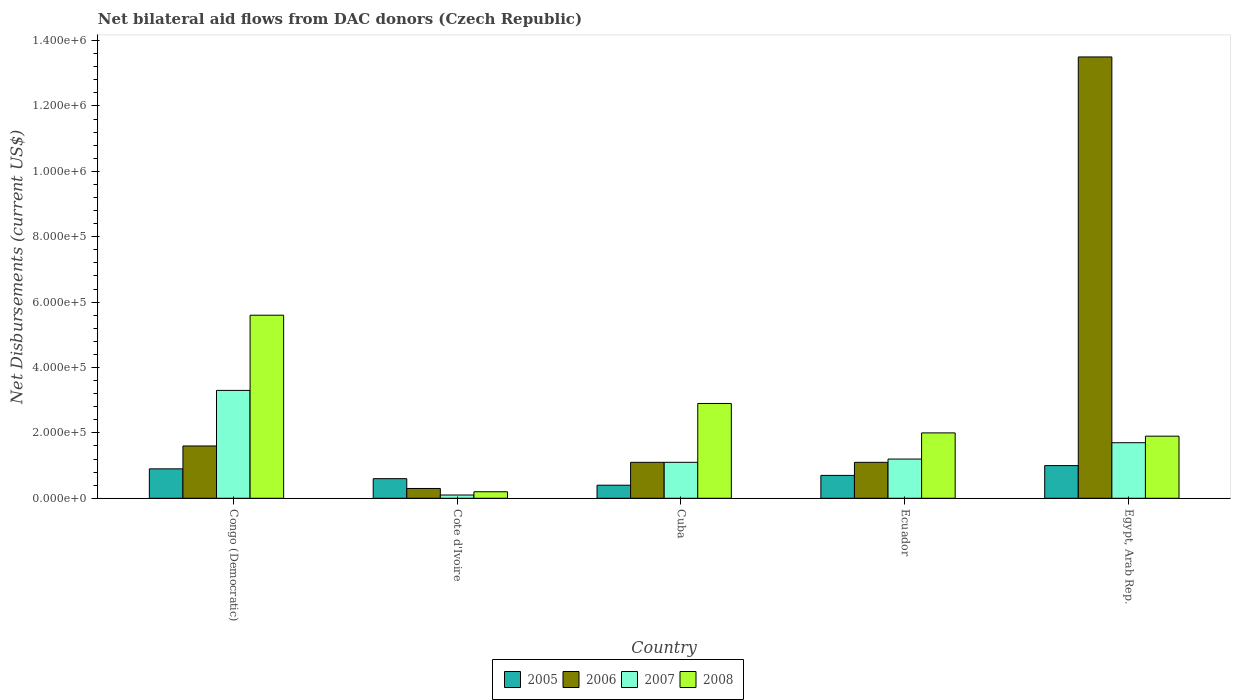How many groups of bars are there?
Offer a very short reply. 5. Are the number of bars per tick equal to the number of legend labels?
Provide a short and direct response. Yes. How many bars are there on the 5th tick from the left?
Make the answer very short. 4. How many bars are there on the 5th tick from the right?
Your response must be concise. 4. What is the label of the 3rd group of bars from the left?
Your answer should be compact. Cuba. In which country was the net bilateral aid flows in 2005 maximum?
Keep it short and to the point. Egypt, Arab Rep. In which country was the net bilateral aid flows in 2008 minimum?
Ensure brevity in your answer.  Cote d'Ivoire. What is the total net bilateral aid flows in 2006 in the graph?
Provide a short and direct response. 1.76e+06. What is the difference between the net bilateral aid flows in 2005 in Congo (Democratic) and the net bilateral aid flows in 2006 in Ecuador?
Your answer should be compact. -2.00e+04. What is the average net bilateral aid flows in 2005 per country?
Make the answer very short. 7.20e+04. What is the difference between the net bilateral aid flows of/in 2005 and net bilateral aid flows of/in 2007 in Ecuador?
Your answer should be compact. -5.00e+04. In how many countries, is the net bilateral aid flows in 2008 greater than 600000 US$?
Keep it short and to the point. 0. What is the ratio of the net bilateral aid flows in 2006 in Congo (Democratic) to that in Egypt, Arab Rep.?
Your answer should be compact. 0.12. Is the net bilateral aid flows in 2005 in Congo (Democratic) less than that in Ecuador?
Provide a short and direct response. No. What is the difference between the highest and the second highest net bilateral aid flows in 2008?
Provide a succinct answer. 3.60e+05. In how many countries, is the net bilateral aid flows in 2005 greater than the average net bilateral aid flows in 2005 taken over all countries?
Offer a very short reply. 2. Is the sum of the net bilateral aid flows in 2005 in Cuba and Ecuador greater than the maximum net bilateral aid flows in 2006 across all countries?
Make the answer very short. No. Is it the case that in every country, the sum of the net bilateral aid flows in 2006 and net bilateral aid flows in 2005 is greater than the sum of net bilateral aid flows in 2007 and net bilateral aid flows in 2008?
Keep it short and to the point. No. What does the 1st bar from the left in Egypt, Arab Rep. represents?
Your answer should be compact. 2005. What does the 1st bar from the right in Cote d'Ivoire represents?
Your response must be concise. 2008. Is it the case that in every country, the sum of the net bilateral aid flows in 2008 and net bilateral aid flows in 2006 is greater than the net bilateral aid flows in 2005?
Provide a short and direct response. No. How many countries are there in the graph?
Provide a short and direct response. 5. Are the values on the major ticks of Y-axis written in scientific E-notation?
Your answer should be very brief. Yes. Does the graph contain any zero values?
Your response must be concise. No. Where does the legend appear in the graph?
Offer a terse response. Bottom center. What is the title of the graph?
Provide a short and direct response. Net bilateral aid flows from DAC donors (Czech Republic). What is the label or title of the X-axis?
Your answer should be compact. Country. What is the label or title of the Y-axis?
Make the answer very short. Net Disbursements (current US$). What is the Net Disbursements (current US$) of 2006 in Congo (Democratic)?
Your answer should be very brief. 1.60e+05. What is the Net Disbursements (current US$) of 2008 in Congo (Democratic)?
Give a very brief answer. 5.60e+05. What is the Net Disbursements (current US$) in 2005 in Cote d'Ivoire?
Your answer should be very brief. 6.00e+04. What is the Net Disbursements (current US$) of 2008 in Cote d'Ivoire?
Ensure brevity in your answer.  2.00e+04. What is the Net Disbursements (current US$) of 2005 in Cuba?
Offer a terse response. 4.00e+04. What is the Net Disbursements (current US$) of 2007 in Cuba?
Your answer should be very brief. 1.10e+05. What is the Net Disbursements (current US$) in 2008 in Cuba?
Your answer should be very brief. 2.90e+05. What is the Net Disbursements (current US$) in 2006 in Egypt, Arab Rep.?
Give a very brief answer. 1.35e+06. What is the Net Disbursements (current US$) in 2007 in Egypt, Arab Rep.?
Provide a short and direct response. 1.70e+05. What is the Net Disbursements (current US$) in 2008 in Egypt, Arab Rep.?
Offer a very short reply. 1.90e+05. Across all countries, what is the maximum Net Disbursements (current US$) in 2006?
Give a very brief answer. 1.35e+06. Across all countries, what is the maximum Net Disbursements (current US$) of 2008?
Provide a succinct answer. 5.60e+05. Across all countries, what is the minimum Net Disbursements (current US$) in 2005?
Your answer should be compact. 4.00e+04. Across all countries, what is the minimum Net Disbursements (current US$) in 2008?
Make the answer very short. 2.00e+04. What is the total Net Disbursements (current US$) of 2006 in the graph?
Offer a very short reply. 1.76e+06. What is the total Net Disbursements (current US$) of 2007 in the graph?
Ensure brevity in your answer.  7.40e+05. What is the total Net Disbursements (current US$) in 2008 in the graph?
Keep it short and to the point. 1.26e+06. What is the difference between the Net Disbursements (current US$) in 2008 in Congo (Democratic) and that in Cote d'Ivoire?
Make the answer very short. 5.40e+05. What is the difference between the Net Disbursements (current US$) of 2005 in Congo (Democratic) and that in Cuba?
Provide a succinct answer. 5.00e+04. What is the difference between the Net Disbursements (current US$) in 2006 in Congo (Democratic) and that in Cuba?
Ensure brevity in your answer.  5.00e+04. What is the difference between the Net Disbursements (current US$) of 2007 in Congo (Democratic) and that in Cuba?
Your response must be concise. 2.20e+05. What is the difference between the Net Disbursements (current US$) of 2008 in Congo (Democratic) and that in Cuba?
Make the answer very short. 2.70e+05. What is the difference between the Net Disbursements (current US$) of 2006 in Congo (Democratic) and that in Ecuador?
Provide a succinct answer. 5.00e+04. What is the difference between the Net Disbursements (current US$) in 2005 in Congo (Democratic) and that in Egypt, Arab Rep.?
Provide a short and direct response. -10000. What is the difference between the Net Disbursements (current US$) of 2006 in Congo (Democratic) and that in Egypt, Arab Rep.?
Ensure brevity in your answer.  -1.19e+06. What is the difference between the Net Disbursements (current US$) in 2007 in Congo (Democratic) and that in Egypt, Arab Rep.?
Give a very brief answer. 1.60e+05. What is the difference between the Net Disbursements (current US$) of 2008 in Congo (Democratic) and that in Egypt, Arab Rep.?
Offer a very short reply. 3.70e+05. What is the difference between the Net Disbursements (current US$) in 2005 in Cote d'Ivoire and that in Cuba?
Offer a very short reply. 2.00e+04. What is the difference between the Net Disbursements (current US$) in 2006 in Cote d'Ivoire and that in Cuba?
Your answer should be very brief. -8.00e+04. What is the difference between the Net Disbursements (current US$) in 2007 in Cote d'Ivoire and that in Cuba?
Ensure brevity in your answer.  -1.00e+05. What is the difference between the Net Disbursements (current US$) in 2008 in Cote d'Ivoire and that in Cuba?
Give a very brief answer. -2.70e+05. What is the difference between the Net Disbursements (current US$) in 2007 in Cote d'Ivoire and that in Ecuador?
Keep it short and to the point. -1.10e+05. What is the difference between the Net Disbursements (current US$) of 2008 in Cote d'Ivoire and that in Ecuador?
Your answer should be compact. -1.80e+05. What is the difference between the Net Disbursements (current US$) of 2005 in Cote d'Ivoire and that in Egypt, Arab Rep.?
Offer a terse response. -4.00e+04. What is the difference between the Net Disbursements (current US$) in 2006 in Cote d'Ivoire and that in Egypt, Arab Rep.?
Keep it short and to the point. -1.32e+06. What is the difference between the Net Disbursements (current US$) in 2007 in Cote d'Ivoire and that in Egypt, Arab Rep.?
Provide a short and direct response. -1.60e+05. What is the difference between the Net Disbursements (current US$) of 2005 in Cuba and that in Ecuador?
Provide a short and direct response. -3.00e+04. What is the difference between the Net Disbursements (current US$) in 2006 in Cuba and that in Ecuador?
Ensure brevity in your answer.  0. What is the difference between the Net Disbursements (current US$) of 2005 in Cuba and that in Egypt, Arab Rep.?
Your response must be concise. -6.00e+04. What is the difference between the Net Disbursements (current US$) of 2006 in Cuba and that in Egypt, Arab Rep.?
Offer a terse response. -1.24e+06. What is the difference between the Net Disbursements (current US$) of 2008 in Cuba and that in Egypt, Arab Rep.?
Your response must be concise. 1.00e+05. What is the difference between the Net Disbursements (current US$) of 2005 in Ecuador and that in Egypt, Arab Rep.?
Offer a terse response. -3.00e+04. What is the difference between the Net Disbursements (current US$) of 2006 in Ecuador and that in Egypt, Arab Rep.?
Provide a short and direct response. -1.24e+06. What is the difference between the Net Disbursements (current US$) of 2007 in Ecuador and that in Egypt, Arab Rep.?
Provide a succinct answer. -5.00e+04. What is the difference between the Net Disbursements (current US$) of 2008 in Ecuador and that in Egypt, Arab Rep.?
Provide a succinct answer. 10000. What is the difference between the Net Disbursements (current US$) in 2005 in Congo (Democratic) and the Net Disbursements (current US$) in 2008 in Cote d'Ivoire?
Provide a short and direct response. 7.00e+04. What is the difference between the Net Disbursements (current US$) of 2006 in Congo (Democratic) and the Net Disbursements (current US$) of 2007 in Cote d'Ivoire?
Ensure brevity in your answer.  1.50e+05. What is the difference between the Net Disbursements (current US$) of 2007 in Congo (Democratic) and the Net Disbursements (current US$) of 2008 in Cote d'Ivoire?
Provide a short and direct response. 3.10e+05. What is the difference between the Net Disbursements (current US$) of 2005 in Congo (Democratic) and the Net Disbursements (current US$) of 2007 in Cuba?
Ensure brevity in your answer.  -2.00e+04. What is the difference between the Net Disbursements (current US$) in 2005 in Congo (Democratic) and the Net Disbursements (current US$) in 2008 in Cuba?
Your answer should be very brief. -2.00e+05. What is the difference between the Net Disbursements (current US$) in 2006 in Congo (Democratic) and the Net Disbursements (current US$) in 2008 in Cuba?
Provide a succinct answer. -1.30e+05. What is the difference between the Net Disbursements (current US$) in 2007 in Congo (Democratic) and the Net Disbursements (current US$) in 2008 in Cuba?
Your answer should be compact. 4.00e+04. What is the difference between the Net Disbursements (current US$) of 2005 in Congo (Democratic) and the Net Disbursements (current US$) of 2007 in Ecuador?
Provide a succinct answer. -3.00e+04. What is the difference between the Net Disbursements (current US$) of 2006 in Congo (Democratic) and the Net Disbursements (current US$) of 2007 in Ecuador?
Provide a succinct answer. 4.00e+04. What is the difference between the Net Disbursements (current US$) in 2006 in Congo (Democratic) and the Net Disbursements (current US$) in 2008 in Ecuador?
Give a very brief answer. -4.00e+04. What is the difference between the Net Disbursements (current US$) in 2005 in Congo (Democratic) and the Net Disbursements (current US$) in 2006 in Egypt, Arab Rep.?
Ensure brevity in your answer.  -1.26e+06. What is the difference between the Net Disbursements (current US$) of 2005 in Cote d'Ivoire and the Net Disbursements (current US$) of 2008 in Cuba?
Make the answer very short. -2.30e+05. What is the difference between the Net Disbursements (current US$) in 2006 in Cote d'Ivoire and the Net Disbursements (current US$) in 2008 in Cuba?
Offer a terse response. -2.60e+05. What is the difference between the Net Disbursements (current US$) in 2007 in Cote d'Ivoire and the Net Disbursements (current US$) in 2008 in Cuba?
Ensure brevity in your answer.  -2.80e+05. What is the difference between the Net Disbursements (current US$) of 2005 in Cote d'Ivoire and the Net Disbursements (current US$) of 2008 in Ecuador?
Ensure brevity in your answer.  -1.40e+05. What is the difference between the Net Disbursements (current US$) in 2006 in Cote d'Ivoire and the Net Disbursements (current US$) in 2008 in Ecuador?
Provide a short and direct response. -1.70e+05. What is the difference between the Net Disbursements (current US$) in 2007 in Cote d'Ivoire and the Net Disbursements (current US$) in 2008 in Ecuador?
Your response must be concise. -1.90e+05. What is the difference between the Net Disbursements (current US$) in 2005 in Cote d'Ivoire and the Net Disbursements (current US$) in 2006 in Egypt, Arab Rep.?
Offer a very short reply. -1.29e+06. What is the difference between the Net Disbursements (current US$) of 2005 in Cote d'Ivoire and the Net Disbursements (current US$) of 2008 in Egypt, Arab Rep.?
Give a very brief answer. -1.30e+05. What is the difference between the Net Disbursements (current US$) of 2006 in Cote d'Ivoire and the Net Disbursements (current US$) of 2008 in Egypt, Arab Rep.?
Provide a succinct answer. -1.60e+05. What is the difference between the Net Disbursements (current US$) in 2005 in Cuba and the Net Disbursements (current US$) in 2007 in Ecuador?
Make the answer very short. -8.00e+04. What is the difference between the Net Disbursements (current US$) of 2005 in Cuba and the Net Disbursements (current US$) of 2008 in Ecuador?
Provide a succinct answer. -1.60e+05. What is the difference between the Net Disbursements (current US$) of 2006 in Cuba and the Net Disbursements (current US$) of 2008 in Ecuador?
Make the answer very short. -9.00e+04. What is the difference between the Net Disbursements (current US$) in 2005 in Cuba and the Net Disbursements (current US$) in 2006 in Egypt, Arab Rep.?
Keep it short and to the point. -1.31e+06. What is the difference between the Net Disbursements (current US$) in 2005 in Cuba and the Net Disbursements (current US$) in 2007 in Egypt, Arab Rep.?
Give a very brief answer. -1.30e+05. What is the difference between the Net Disbursements (current US$) of 2006 in Cuba and the Net Disbursements (current US$) of 2007 in Egypt, Arab Rep.?
Offer a very short reply. -6.00e+04. What is the difference between the Net Disbursements (current US$) of 2006 in Cuba and the Net Disbursements (current US$) of 2008 in Egypt, Arab Rep.?
Offer a very short reply. -8.00e+04. What is the difference between the Net Disbursements (current US$) in 2007 in Cuba and the Net Disbursements (current US$) in 2008 in Egypt, Arab Rep.?
Offer a terse response. -8.00e+04. What is the difference between the Net Disbursements (current US$) of 2005 in Ecuador and the Net Disbursements (current US$) of 2006 in Egypt, Arab Rep.?
Offer a very short reply. -1.28e+06. What is the difference between the Net Disbursements (current US$) in 2005 in Ecuador and the Net Disbursements (current US$) in 2007 in Egypt, Arab Rep.?
Your answer should be very brief. -1.00e+05. What is the difference between the Net Disbursements (current US$) in 2005 in Ecuador and the Net Disbursements (current US$) in 2008 in Egypt, Arab Rep.?
Keep it short and to the point. -1.20e+05. What is the difference between the Net Disbursements (current US$) of 2006 in Ecuador and the Net Disbursements (current US$) of 2007 in Egypt, Arab Rep.?
Give a very brief answer. -6.00e+04. What is the difference between the Net Disbursements (current US$) in 2007 in Ecuador and the Net Disbursements (current US$) in 2008 in Egypt, Arab Rep.?
Offer a terse response. -7.00e+04. What is the average Net Disbursements (current US$) of 2005 per country?
Ensure brevity in your answer.  7.20e+04. What is the average Net Disbursements (current US$) in 2006 per country?
Offer a very short reply. 3.52e+05. What is the average Net Disbursements (current US$) of 2007 per country?
Your response must be concise. 1.48e+05. What is the average Net Disbursements (current US$) of 2008 per country?
Your answer should be compact. 2.52e+05. What is the difference between the Net Disbursements (current US$) of 2005 and Net Disbursements (current US$) of 2007 in Congo (Democratic)?
Keep it short and to the point. -2.40e+05. What is the difference between the Net Disbursements (current US$) in 2005 and Net Disbursements (current US$) in 2008 in Congo (Democratic)?
Your response must be concise. -4.70e+05. What is the difference between the Net Disbursements (current US$) of 2006 and Net Disbursements (current US$) of 2007 in Congo (Democratic)?
Your answer should be very brief. -1.70e+05. What is the difference between the Net Disbursements (current US$) of 2006 and Net Disbursements (current US$) of 2008 in Congo (Democratic)?
Offer a terse response. -4.00e+05. What is the difference between the Net Disbursements (current US$) of 2005 and Net Disbursements (current US$) of 2006 in Cote d'Ivoire?
Ensure brevity in your answer.  3.00e+04. What is the difference between the Net Disbursements (current US$) in 2006 and Net Disbursements (current US$) in 2007 in Cote d'Ivoire?
Provide a short and direct response. 2.00e+04. What is the difference between the Net Disbursements (current US$) in 2006 and Net Disbursements (current US$) in 2008 in Cote d'Ivoire?
Give a very brief answer. 10000. What is the difference between the Net Disbursements (current US$) in 2005 and Net Disbursements (current US$) in 2007 in Cuba?
Ensure brevity in your answer.  -7.00e+04. What is the difference between the Net Disbursements (current US$) in 2005 and Net Disbursements (current US$) in 2008 in Cuba?
Your answer should be compact. -2.50e+05. What is the difference between the Net Disbursements (current US$) in 2007 and Net Disbursements (current US$) in 2008 in Cuba?
Make the answer very short. -1.80e+05. What is the difference between the Net Disbursements (current US$) of 2005 and Net Disbursements (current US$) of 2006 in Ecuador?
Your answer should be compact. -4.00e+04. What is the difference between the Net Disbursements (current US$) in 2006 and Net Disbursements (current US$) in 2007 in Ecuador?
Ensure brevity in your answer.  -10000. What is the difference between the Net Disbursements (current US$) of 2005 and Net Disbursements (current US$) of 2006 in Egypt, Arab Rep.?
Keep it short and to the point. -1.25e+06. What is the difference between the Net Disbursements (current US$) in 2005 and Net Disbursements (current US$) in 2008 in Egypt, Arab Rep.?
Offer a terse response. -9.00e+04. What is the difference between the Net Disbursements (current US$) of 2006 and Net Disbursements (current US$) of 2007 in Egypt, Arab Rep.?
Your answer should be very brief. 1.18e+06. What is the difference between the Net Disbursements (current US$) of 2006 and Net Disbursements (current US$) of 2008 in Egypt, Arab Rep.?
Provide a short and direct response. 1.16e+06. What is the difference between the Net Disbursements (current US$) of 2007 and Net Disbursements (current US$) of 2008 in Egypt, Arab Rep.?
Your response must be concise. -2.00e+04. What is the ratio of the Net Disbursements (current US$) of 2005 in Congo (Democratic) to that in Cote d'Ivoire?
Make the answer very short. 1.5. What is the ratio of the Net Disbursements (current US$) of 2006 in Congo (Democratic) to that in Cote d'Ivoire?
Offer a very short reply. 5.33. What is the ratio of the Net Disbursements (current US$) in 2007 in Congo (Democratic) to that in Cote d'Ivoire?
Offer a terse response. 33. What is the ratio of the Net Disbursements (current US$) in 2005 in Congo (Democratic) to that in Cuba?
Keep it short and to the point. 2.25. What is the ratio of the Net Disbursements (current US$) in 2006 in Congo (Democratic) to that in Cuba?
Your answer should be very brief. 1.45. What is the ratio of the Net Disbursements (current US$) in 2008 in Congo (Democratic) to that in Cuba?
Provide a succinct answer. 1.93. What is the ratio of the Net Disbursements (current US$) in 2005 in Congo (Democratic) to that in Ecuador?
Your answer should be compact. 1.29. What is the ratio of the Net Disbursements (current US$) of 2006 in Congo (Democratic) to that in Ecuador?
Your answer should be compact. 1.45. What is the ratio of the Net Disbursements (current US$) in 2007 in Congo (Democratic) to that in Ecuador?
Your response must be concise. 2.75. What is the ratio of the Net Disbursements (current US$) in 2008 in Congo (Democratic) to that in Ecuador?
Offer a terse response. 2.8. What is the ratio of the Net Disbursements (current US$) of 2006 in Congo (Democratic) to that in Egypt, Arab Rep.?
Give a very brief answer. 0.12. What is the ratio of the Net Disbursements (current US$) of 2007 in Congo (Democratic) to that in Egypt, Arab Rep.?
Offer a very short reply. 1.94. What is the ratio of the Net Disbursements (current US$) of 2008 in Congo (Democratic) to that in Egypt, Arab Rep.?
Offer a terse response. 2.95. What is the ratio of the Net Disbursements (current US$) of 2006 in Cote d'Ivoire to that in Cuba?
Provide a short and direct response. 0.27. What is the ratio of the Net Disbursements (current US$) of 2007 in Cote d'Ivoire to that in Cuba?
Provide a short and direct response. 0.09. What is the ratio of the Net Disbursements (current US$) in 2008 in Cote d'Ivoire to that in Cuba?
Your response must be concise. 0.07. What is the ratio of the Net Disbursements (current US$) of 2006 in Cote d'Ivoire to that in Ecuador?
Ensure brevity in your answer.  0.27. What is the ratio of the Net Disbursements (current US$) in 2007 in Cote d'Ivoire to that in Ecuador?
Provide a succinct answer. 0.08. What is the ratio of the Net Disbursements (current US$) in 2005 in Cote d'Ivoire to that in Egypt, Arab Rep.?
Offer a terse response. 0.6. What is the ratio of the Net Disbursements (current US$) of 2006 in Cote d'Ivoire to that in Egypt, Arab Rep.?
Make the answer very short. 0.02. What is the ratio of the Net Disbursements (current US$) in 2007 in Cote d'Ivoire to that in Egypt, Arab Rep.?
Offer a terse response. 0.06. What is the ratio of the Net Disbursements (current US$) of 2008 in Cote d'Ivoire to that in Egypt, Arab Rep.?
Provide a succinct answer. 0.11. What is the ratio of the Net Disbursements (current US$) in 2005 in Cuba to that in Ecuador?
Offer a very short reply. 0.57. What is the ratio of the Net Disbursements (current US$) in 2006 in Cuba to that in Ecuador?
Offer a terse response. 1. What is the ratio of the Net Disbursements (current US$) in 2008 in Cuba to that in Ecuador?
Make the answer very short. 1.45. What is the ratio of the Net Disbursements (current US$) in 2006 in Cuba to that in Egypt, Arab Rep.?
Give a very brief answer. 0.08. What is the ratio of the Net Disbursements (current US$) of 2007 in Cuba to that in Egypt, Arab Rep.?
Ensure brevity in your answer.  0.65. What is the ratio of the Net Disbursements (current US$) in 2008 in Cuba to that in Egypt, Arab Rep.?
Provide a short and direct response. 1.53. What is the ratio of the Net Disbursements (current US$) in 2005 in Ecuador to that in Egypt, Arab Rep.?
Provide a succinct answer. 0.7. What is the ratio of the Net Disbursements (current US$) in 2006 in Ecuador to that in Egypt, Arab Rep.?
Keep it short and to the point. 0.08. What is the ratio of the Net Disbursements (current US$) of 2007 in Ecuador to that in Egypt, Arab Rep.?
Your answer should be very brief. 0.71. What is the ratio of the Net Disbursements (current US$) of 2008 in Ecuador to that in Egypt, Arab Rep.?
Make the answer very short. 1.05. What is the difference between the highest and the second highest Net Disbursements (current US$) in 2006?
Provide a short and direct response. 1.19e+06. What is the difference between the highest and the second highest Net Disbursements (current US$) of 2007?
Your answer should be very brief. 1.60e+05. What is the difference between the highest and the second highest Net Disbursements (current US$) of 2008?
Ensure brevity in your answer.  2.70e+05. What is the difference between the highest and the lowest Net Disbursements (current US$) in 2006?
Offer a terse response. 1.32e+06. What is the difference between the highest and the lowest Net Disbursements (current US$) of 2008?
Keep it short and to the point. 5.40e+05. 